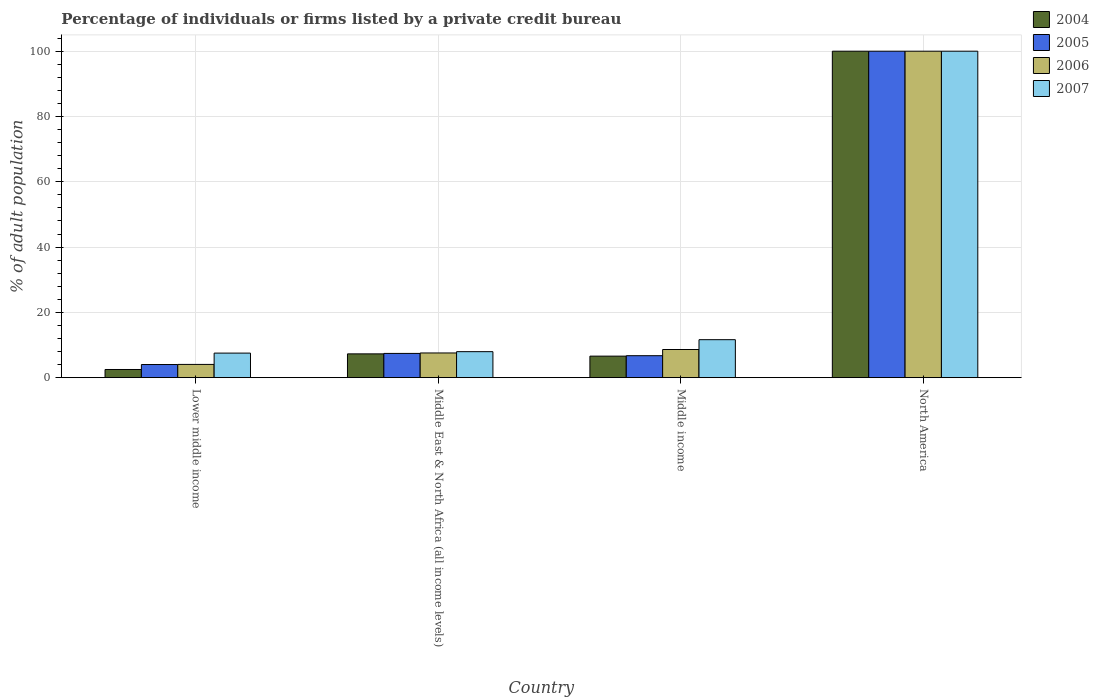How many groups of bars are there?
Your answer should be compact. 4. How many bars are there on the 4th tick from the right?
Offer a very short reply. 4. In how many cases, is the number of bars for a given country not equal to the number of legend labels?
Offer a very short reply. 0. What is the percentage of population listed by a private credit bureau in 2004 in Lower middle income?
Your answer should be very brief. 2.5. Across all countries, what is the maximum percentage of population listed by a private credit bureau in 2005?
Provide a succinct answer. 100. Across all countries, what is the minimum percentage of population listed by a private credit bureau in 2004?
Offer a terse response. 2.5. In which country was the percentage of population listed by a private credit bureau in 2007 minimum?
Keep it short and to the point. Lower middle income. What is the total percentage of population listed by a private credit bureau in 2007 in the graph?
Your answer should be compact. 127.12. What is the difference between the percentage of population listed by a private credit bureau in 2005 in Lower middle income and that in Middle East & North Africa (all income levels)?
Give a very brief answer. -3.4. What is the difference between the percentage of population listed by a private credit bureau in 2005 in Middle East & North Africa (all income levels) and the percentage of population listed by a private credit bureau in 2004 in Lower middle income?
Your answer should be very brief. 4.93. What is the average percentage of population listed by a private credit bureau in 2005 per country?
Offer a terse response. 29.55. What is the difference between the percentage of population listed by a private credit bureau of/in 2004 and percentage of population listed by a private credit bureau of/in 2007 in Middle East & North Africa (all income levels)?
Your response must be concise. -0.68. In how many countries, is the percentage of population listed by a private credit bureau in 2006 greater than 24 %?
Make the answer very short. 1. What is the ratio of the percentage of population listed by a private credit bureau in 2004 in Lower middle income to that in North America?
Offer a terse response. 0.03. Is the difference between the percentage of population listed by a private credit bureau in 2004 in Middle East & North Africa (all income levels) and North America greater than the difference between the percentage of population listed by a private credit bureau in 2007 in Middle East & North Africa (all income levels) and North America?
Offer a very short reply. No. What is the difference between the highest and the second highest percentage of population listed by a private credit bureau in 2007?
Make the answer very short. -88.37. What is the difference between the highest and the lowest percentage of population listed by a private credit bureau in 2005?
Provide a short and direct response. 95.97. What does the 4th bar from the right in Lower middle income represents?
Offer a terse response. 2004. Are all the bars in the graph horizontal?
Keep it short and to the point. No. How many countries are there in the graph?
Offer a very short reply. 4. Are the values on the major ticks of Y-axis written in scientific E-notation?
Your response must be concise. No. How many legend labels are there?
Ensure brevity in your answer.  4. What is the title of the graph?
Keep it short and to the point. Percentage of individuals or firms listed by a private credit bureau. Does "1994" appear as one of the legend labels in the graph?
Offer a very short reply. No. What is the label or title of the X-axis?
Your answer should be very brief. Country. What is the label or title of the Y-axis?
Offer a terse response. % of adult population. What is the % of adult population of 2004 in Lower middle income?
Provide a succinct answer. 2.5. What is the % of adult population of 2005 in Lower middle income?
Keep it short and to the point. 4.03. What is the % of adult population in 2006 in Lower middle income?
Your answer should be very brief. 4.06. What is the % of adult population in 2007 in Lower middle income?
Provide a succinct answer. 7.53. What is the % of adult population of 2004 in Middle East & North Africa (all income levels)?
Offer a terse response. 7.29. What is the % of adult population of 2005 in Middle East & North Africa (all income levels)?
Your answer should be compact. 7.43. What is the % of adult population of 2006 in Middle East & North Africa (all income levels)?
Offer a very short reply. 7.56. What is the % of adult population of 2007 in Middle East & North Africa (all income levels)?
Provide a short and direct response. 7.96. What is the % of adult population of 2004 in Middle income?
Offer a very short reply. 6.6. What is the % of adult population in 2005 in Middle income?
Offer a very short reply. 6.73. What is the % of adult population of 2006 in Middle income?
Your answer should be very brief. 8.62. What is the % of adult population of 2007 in Middle income?
Your response must be concise. 11.63. What is the % of adult population in 2004 in North America?
Your answer should be very brief. 100. What is the % of adult population in 2006 in North America?
Give a very brief answer. 100. Across all countries, what is the maximum % of adult population in 2004?
Provide a short and direct response. 100. Across all countries, what is the maximum % of adult population of 2005?
Give a very brief answer. 100. Across all countries, what is the maximum % of adult population in 2006?
Keep it short and to the point. 100. Across all countries, what is the minimum % of adult population of 2004?
Your answer should be compact. 2.5. Across all countries, what is the minimum % of adult population in 2005?
Offer a very short reply. 4.03. Across all countries, what is the minimum % of adult population of 2006?
Give a very brief answer. 4.06. Across all countries, what is the minimum % of adult population of 2007?
Provide a succinct answer. 7.53. What is the total % of adult population of 2004 in the graph?
Your answer should be compact. 116.39. What is the total % of adult population in 2005 in the graph?
Offer a terse response. 118.18. What is the total % of adult population of 2006 in the graph?
Offer a very short reply. 120.25. What is the total % of adult population of 2007 in the graph?
Provide a short and direct response. 127.12. What is the difference between the % of adult population in 2004 in Lower middle income and that in Middle East & North Africa (all income levels)?
Your answer should be very brief. -4.79. What is the difference between the % of adult population in 2005 in Lower middle income and that in Middle East & North Africa (all income levels)?
Give a very brief answer. -3.4. What is the difference between the % of adult population in 2006 in Lower middle income and that in Middle East & North Africa (all income levels)?
Your response must be concise. -3.51. What is the difference between the % of adult population in 2007 in Lower middle income and that in Middle East & North Africa (all income levels)?
Make the answer very short. -0.44. What is the difference between the % of adult population in 2004 in Lower middle income and that in Middle income?
Your answer should be very brief. -4.09. What is the difference between the % of adult population of 2005 in Lower middle income and that in Middle income?
Offer a very short reply. -2.7. What is the difference between the % of adult population of 2006 in Lower middle income and that in Middle income?
Your answer should be compact. -4.57. What is the difference between the % of adult population of 2007 in Lower middle income and that in Middle income?
Give a very brief answer. -4.11. What is the difference between the % of adult population of 2004 in Lower middle income and that in North America?
Your response must be concise. -97.5. What is the difference between the % of adult population of 2005 in Lower middle income and that in North America?
Make the answer very short. -95.97. What is the difference between the % of adult population of 2006 in Lower middle income and that in North America?
Your answer should be very brief. -95.94. What is the difference between the % of adult population of 2007 in Lower middle income and that in North America?
Your answer should be very brief. -92.47. What is the difference between the % of adult population of 2004 in Middle East & North Africa (all income levels) and that in Middle income?
Provide a succinct answer. 0.69. What is the difference between the % of adult population in 2005 in Middle East & North Africa (all income levels) and that in Middle income?
Keep it short and to the point. 0.7. What is the difference between the % of adult population of 2006 in Middle East & North Africa (all income levels) and that in Middle income?
Give a very brief answer. -1.06. What is the difference between the % of adult population of 2007 in Middle East & North Africa (all income levels) and that in Middle income?
Provide a short and direct response. -3.67. What is the difference between the % of adult population of 2004 in Middle East & North Africa (all income levels) and that in North America?
Ensure brevity in your answer.  -92.71. What is the difference between the % of adult population of 2005 in Middle East & North Africa (all income levels) and that in North America?
Your response must be concise. -92.57. What is the difference between the % of adult population in 2006 in Middle East & North Africa (all income levels) and that in North America?
Offer a terse response. -92.44. What is the difference between the % of adult population in 2007 in Middle East & North Africa (all income levels) and that in North America?
Give a very brief answer. -92.04. What is the difference between the % of adult population of 2004 in Middle income and that in North America?
Your response must be concise. -93.4. What is the difference between the % of adult population in 2005 in Middle income and that in North America?
Give a very brief answer. -93.27. What is the difference between the % of adult population in 2006 in Middle income and that in North America?
Make the answer very short. -91.38. What is the difference between the % of adult population of 2007 in Middle income and that in North America?
Offer a very short reply. -88.37. What is the difference between the % of adult population in 2004 in Lower middle income and the % of adult population in 2005 in Middle East & North Africa (all income levels)?
Your response must be concise. -4.93. What is the difference between the % of adult population of 2004 in Lower middle income and the % of adult population of 2006 in Middle East & North Africa (all income levels)?
Your answer should be very brief. -5.06. What is the difference between the % of adult population of 2004 in Lower middle income and the % of adult population of 2007 in Middle East & North Africa (all income levels)?
Your answer should be very brief. -5.46. What is the difference between the % of adult population in 2005 in Lower middle income and the % of adult population in 2006 in Middle East & North Africa (all income levels)?
Your answer should be very brief. -3.54. What is the difference between the % of adult population of 2005 in Lower middle income and the % of adult population of 2007 in Middle East & North Africa (all income levels)?
Keep it short and to the point. -3.94. What is the difference between the % of adult population of 2006 in Lower middle income and the % of adult population of 2007 in Middle East & North Africa (all income levels)?
Your answer should be compact. -3.9. What is the difference between the % of adult population in 2004 in Lower middle income and the % of adult population in 2005 in Middle income?
Offer a very short reply. -4.23. What is the difference between the % of adult population of 2004 in Lower middle income and the % of adult population of 2006 in Middle income?
Keep it short and to the point. -6.12. What is the difference between the % of adult population of 2004 in Lower middle income and the % of adult population of 2007 in Middle income?
Your response must be concise. -9.13. What is the difference between the % of adult population of 2005 in Lower middle income and the % of adult population of 2006 in Middle income?
Provide a succinct answer. -4.6. What is the difference between the % of adult population of 2005 in Lower middle income and the % of adult population of 2007 in Middle income?
Make the answer very short. -7.61. What is the difference between the % of adult population in 2006 in Lower middle income and the % of adult population in 2007 in Middle income?
Your response must be concise. -7.58. What is the difference between the % of adult population of 2004 in Lower middle income and the % of adult population of 2005 in North America?
Give a very brief answer. -97.5. What is the difference between the % of adult population of 2004 in Lower middle income and the % of adult population of 2006 in North America?
Your response must be concise. -97.5. What is the difference between the % of adult population of 2004 in Lower middle income and the % of adult population of 2007 in North America?
Keep it short and to the point. -97.5. What is the difference between the % of adult population of 2005 in Lower middle income and the % of adult population of 2006 in North America?
Keep it short and to the point. -95.97. What is the difference between the % of adult population in 2005 in Lower middle income and the % of adult population in 2007 in North America?
Your answer should be very brief. -95.97. What is the difference between the % of adult population in 2006 in Lower middle income and the % of adult population in 2007 in North America?
Give a very brief answer. -95.94. What is the difference between the % of adult population in 2004 in Middle East & North Africa (all income levels) and the % of adult population in 2005 in Middle income?
Provide a succinct answer. 0.56. What is the difference between the % of adult population of 2004 in Middle East & North Africa (all income levels) and the % of adult population of 2006 in Middle income?
Provide a succinct answer. -1.34. What is the difference between the % of adult population in 2004 in Middle East & North Africa (all income levels) and the % of adult population in 2007 in Middle income?
Your response must be concise. -4.35. What is the difference between the % of adult population of 2005 in Middle East & North Africa (all income levels) and the % of adult population of 2006 in Middle income?
Offer a terse response. -1.2. What is the difference between the % of adult population of 2005 in Middle East & North Africa (all income levels) and the % of adult population of 2007 in Middle income?
Keep it short and to the point. -4.21. What is the difference between the % of adult population of 2006 in Middle East & North Africa (all income levels) and the % of adult population of 2007 in Middle income?
Your response must be concise. -4.07. What is the difference between the % of adult population in 2004 in Middle East & North Africa (all income levels) and the % of adult population in 2005 in North America?
Ensure brevity in your answer.  -92.71. What is the difference between the % of adult population of 2004 in Middle East & North Africa (all income levels) and the % of adult population of 2006 in North America?
Your answer should be compact. -92.71. What is the difference between the % of adult population of 2004 in Middle East & North Africa (all income levels) and the % of adult population of 2007 in North America?
Keep it short and to the point. -92.71. What is the difference between the % of adult population of 2005 in Middle East & North Africa (all income levels) and the % of adult population of 2006 in North America?
Offer a very short reply. -92.57. What is the difference between the % of adult population in 2005 in Middle East & North Africa (all income levels) and the % of adult population in 2007 in North America?
Offer a very short reply. -92.57. What is the difference between the % of adult population of 2006 in Middle East & North Africa (all income levels) and the % of adult population of 2007 in North America?
Provide a succinct answer. -92.44. What is the difference between the % of adult population of 2004 in Middle income and the % of adult population of 2005 in North America?
Offer a very short reply. -93.4. What is the difference between the % of adult population in 2004 in Middle income and the % of adult population in 2006 in North America?
Offer a terse response. -93.4. What is the difference between the % of adult population in 2004 in Middle income and the % of adult population in 2007 in North America?
Your response must be concise. -93.4. What is the difference between the % of adult population in 2005 in Middle income and the % of adult population in 2006 in North America?
Your response must be concise. -93.27. What is the difference between the % of adult population in 2005 in Middle income and the % of adult population in 2007 in North America?
Your answer should be compact. -93.27. What is the difference between the % of adult population of 2006 in Middle income and the % of adult population of 2007 in North America?
Your answer should be very brief. -91.38. What is the average % of adult population in 2004 per country?
Provide a succinct answer. 29.1. What is the average % of adult population of 2005 per country?
Provide a short and direct response. 29.55. What is the average % of adult population of 2006 per country?
Give a very brief answer. 30.06. What is the average % of adult population of 2007 per country?
Offer a very short reply. 31.78. What is the difference between the % of adult population in 2004 and % of adult population in 2005 in Lower middle income?
Make the answer very short. -1.52. What is the difference between the % of adult population of 2004 and % of adult population of 2006 in Lower middle income?
Your answer should be very brief. -1.56. What is the difference between the % of adult population in 2004 and % of adult population in 2007 in Lower middle income?
Provide a succinct answer. -5.02. What is the difference between the % of adult population of 2005 and % of adult population of 2006 in Lower middle income?
Your answer should be compact. -0.03. What is the difference between the % of adult population of 2005 and % of adult population of 2007 in Lower middle income?
Offer a very short reply. -3.5. What is the difference between the % of adult population in 2006 and % of adult population in 2007 in Lower middle income?
Offer a terse response. -3.47. What is the difference between the % of adult population in 2004 and % of adult population in 2005 in Middle East & North Africa (all income levels)?
Make the answer very short. -0.14. What is the difference between the % of adult population of 2004 and % of adult population of 2006 in Middle East & North Africa (all income levels)?
Provide a succinct answer. -0.28. What is the difference between the % of adult population in 2004 and % of adult population in 2007 in Middle East & North Africa (all income levels)?
Provide a succinct answer. -0.68. What is the difference between the % of adult population of 2005 and % of adult population of 2006 in Middle East & North Africa (all income levels)?
Provide a succinct answer. -0.14. What is the difference between the % of adult population in 2005 and % of adult population in 2007 in Middle East & North Africa (all income levels)?
Ensure brevity in your answer.  -0.53. What is the difference between the % of adult population in 2006 and % of adult population in 2007 in Middle East & North Africa (all income levels)?
Ensure brevity in your answer.  -0.4. What is the difference between the % of adult population of 2004 and % of adult population of 2005 in Middle income?
Give a very brief answer. -0.13. What is the difference between the % of adult population of 2004 and % of adult population of 2006 in Middle income?
Keep it short and to the point. -2.03. What is the difference between the % of adult population in 2004 and % of adult population in 2007 in Middle income?
Your response must be concise. -5.04. What is the difference between the % of adult population of 2005 and % of adult population of 2006 in Middle income?
Keep it short and to the point. -1.9. What is the difference between the % of adult population in 2005 and % of adult population in 2007 in Middle income?
Offer a very short reply. -4.91. What is the difference between the % of adult population of 2006 and % of adult population of 2007 in Middle income?
Keep it short and to the point. -3.01. What is the difference between the % of adult population in 2004 and % of adult population in 2005 in North America?
Your response must be concise. 0. What is the difference between the % of adult population of 2005 and % of adult population of 2007 in North America?
Your answer should be compact. 0. What is the difference between the % of adult population of 2006 and % of adult population of 2007 in North America?
Offer a terse response. 0. What is the ratio of the % of adult population in 2004 in Lower middle income to that in Middle East & North Africa (all income levels)?
Offer a terse response. 0.34. What is the ratio of the % of adult population in 2005 in Lower middle income to that in Middle East & North Africa (all income levels)?
Ensure brevity in your answer.  0.54. What is the ratio of the % of adult population in 2006 in Lower middle income to that in Middle East & North Africa (all income levels)?
Ensure brevity in your answer.  0.54. What is the ratio of the % of adult population of 2007 in Lower middle income to that in Middle East & North Africa (all income levels)?
Offer a terse response. 0.94. What is the ratio of the % of adult population in 2004 in Lower middle income to that in Middle income?
Provide a short and direct response. 0.38. What is the ratio of the % of adult population in 2005 in Lower middle income to that in Middle income?
Keep it short and to the point. 0.6. What is the ratio of the % of adult population of 2006 in Lower middle income to that in Middle income?
Provide a short and direct response. 0.47. What is the ratio of the % of adult population in 2007 in Lower middle income to that in Middle income?
Your answer should be very brief. 0.65. What is the ratio of the % of adult population in 2004 in Lower middle income to that in North America?
Your answer should be compact. 0.03. What is the ratio of the % of adult population of 2005 in Lower middle income to that in North America?
Ensure brevity in your answer.  0.04. What is the ratio of the % of adult population of 2006 in Lower middle income to that in North America?
Provide a succinct answer. 0.04. What is the ratio of the % of adult population of 2007 in Lower middle income to that in North America?
Offer a very short reply. 0.08. What is the ratio of the % of adult population in 2004 in Middle East & North Africa (all income levels) to that in Middle income?
Provide a short and direct response. 1.1. What is the ratio of the % of adult population of 2005 in Middle East & North Africa (all income levels) to that in Middle income?
Offer a terse response. 1.1. What is the ratio of the % of adult population of 2006 in Middle East & North Africa (all income levels) to that in Middle income?
Provide a short and direct response. 0.88. What is the ratio of the % of adult population in 2007 in Middle East & North Africa (all income levels) to that in Middle income?
Make the answer very short. 0.68. What is the ratio of the % of adult population of 2004 in Middle East & North Africa (all income levels) to that in North America?
Ensure brevity in your answer.  0.07. What is the ratio of the % of adult population in 2005 in Middle East & North Africa (all income levels) to that in North America?
Make the answer very short. 0.07. What is the ratio of the % of adult population of 2006 in Middle East & North Africa (all income levels) to that in North America?
Ensure brevity in your answer.  0.08. What is the ratio of the % of adult population in 2007 in Middle East & North Africa (all income levels) to that in North America?
Your response must be concise. 0.08. What is the ratio of the % of adult population in 2004 in Middle income to that in North America?
Make the answer very short. 0.07. What is the ratio of the % of adult population in 2005 in Middle income to that in North America?
Provide a succinct answer. 0.07. What is the ratio of the % of adult population in 2006 in Middle income to that in North America?
Your answer should be compact. 0.09. What is the ratio of the % of adult population of 2007 in Middle income to that in North America?
Your answer should be compact. 0.12. What is the difference between the highest and the second highest % of adult population of 2004?
Offer a terse response. 92.71. What is the difference between the highest and the second highest % of adult population of 2005?
Your answer should be very brief. 92.57. What is the difference between the highest and the second highest % of adult population in 2006?
Keep it short and to the point. 91.38. What is the difference between the highest and the second highest % of adult population of 2007?
Provide a short and direct response. 88.37. What is the difference between the highest and the lowest % of adult population in 2004?
Provide a short and direct response. 97.5. What is the difference between the highest and the lowest % of adult population of 2005?
Your answer should be very brief. 95.97. What is the difference between the highest and the lowest % of adult population in 2006?
Offer a very short reply. 95.94. What is the difference between the highest and the lowest % of adult population in 2007?
Ensure brevity in your answer.  92.47. 